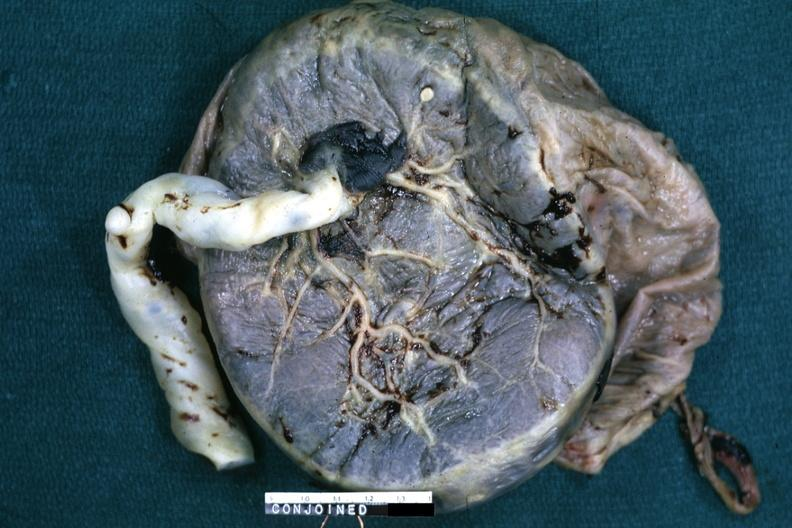what does this image show?
Answer the question using a single word or phrase. Fixed tissue single placenta with very large cord 